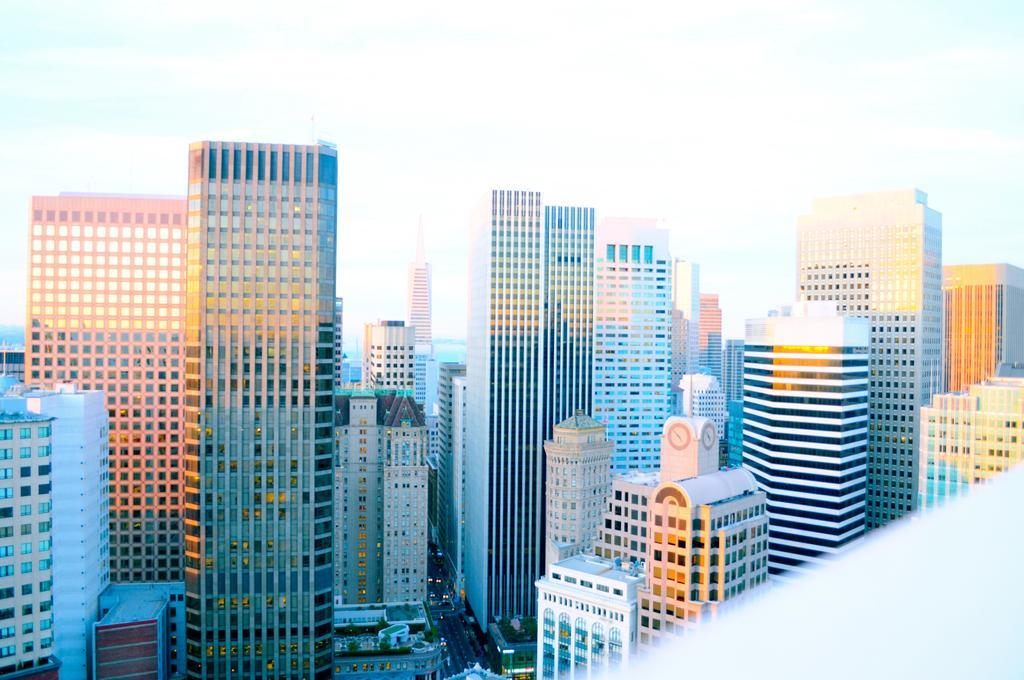In one or two sentences, can you explain what this image depicts? In this picture we can see buildings with windows, vehicles on the road and in the background we can see the sky with clouds. 